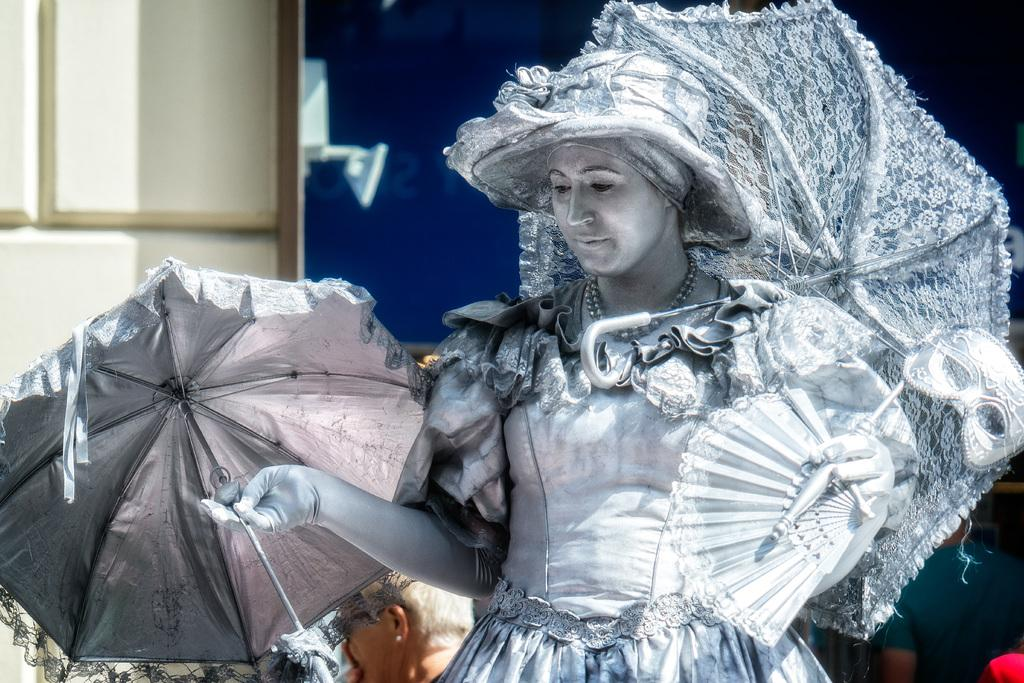What is the person in the image wearing? The person is wearing a costume in the image. What items is the person holding in the image? The person is holding umbrellas and a mask in the image. Can you describe the people at the bottom of the image? There are people at the bottom of the image, but their specific actions or features are not mentioned in the provided facts. What can be seen in the background of the image? There is a wall in the background of the image. What type of fowl is sitting on the cake in the image? There is no cake or fowl present in the image. How many earths can be seen in the image? There is only one earth, and it is not visible in the image. 